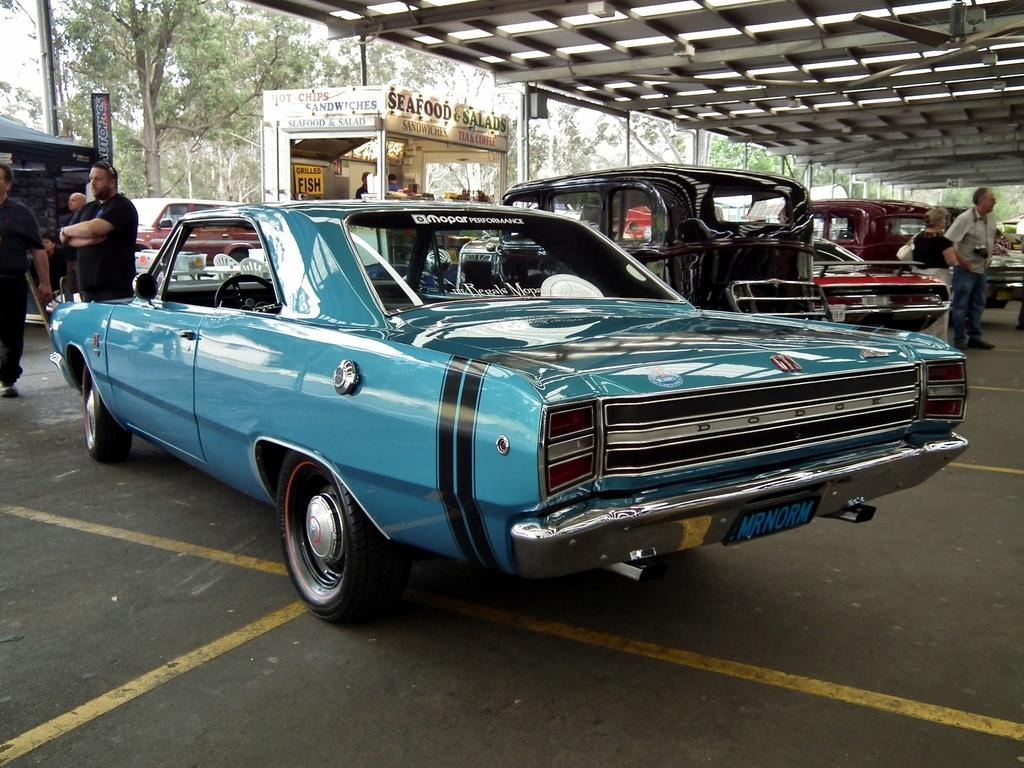What type of vehicles can be seen in the image? There are cars in the image. What else can be seen in the image besides cars? There are people standing in the image, as well as a shed, a shop, and trees. Can you find the receipt for the kitten purchase in the image? There is no receipt or kitten present in the image. Is there a coach visible in the image? There is no coach present in the image. 